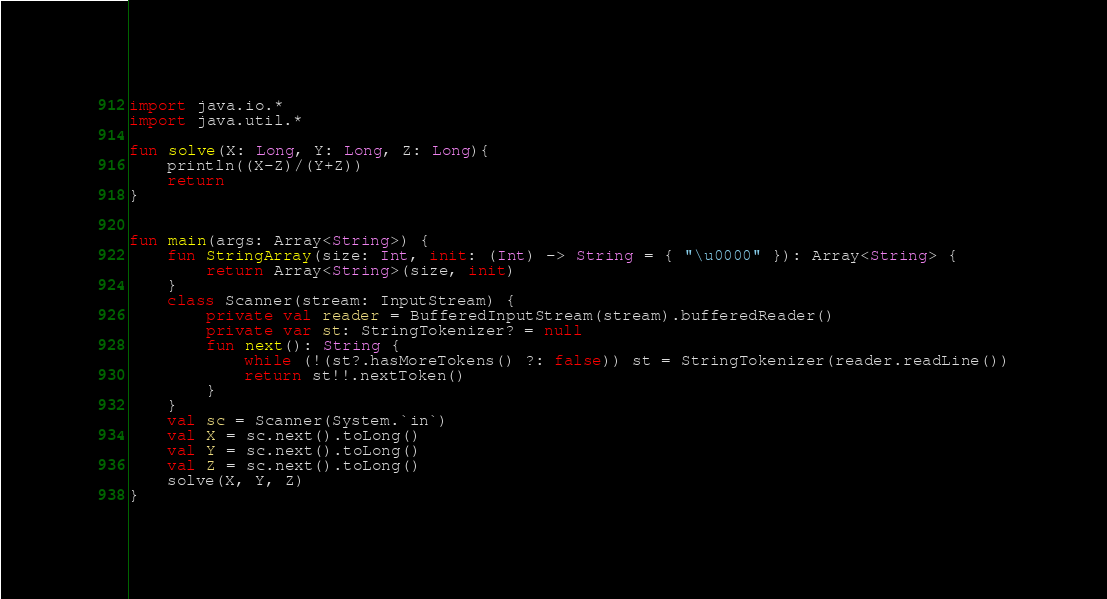<code> <loc_0><loc_0><loc_500><loc_500><_Kotlin_>import java.io.*
import java.util.*

fun solve(X: Long, Y: Long, Z: Long){
    println((X-Z)/(Y+Z))
    return
}


fun main(args: Array<String>) {
    fun StringArray(size: Int, init: (Int) -> String = { "\u0000" }): Array<String> {
        return Array<String>(size, init)
    }
    class Scanner(stream: InputStream) {
        private val reader = BufferedInputStream(stream).bufferedReader()
        private var st: StringTokenizer? = null
        fun next(): String {
            while (!(st?.hasMoreTokens() ?: false)) st = StringTokenizer(reader.readLine())
            return st!!.nextToken()
        }
    }
    val sc = Scanner(System.`in`)
    val X = sc.next().toLong()
    val Y = sc.next().toLong()
    val Z = sc.next().toLong()
    solve(X, Y, Z)
}

</code> 